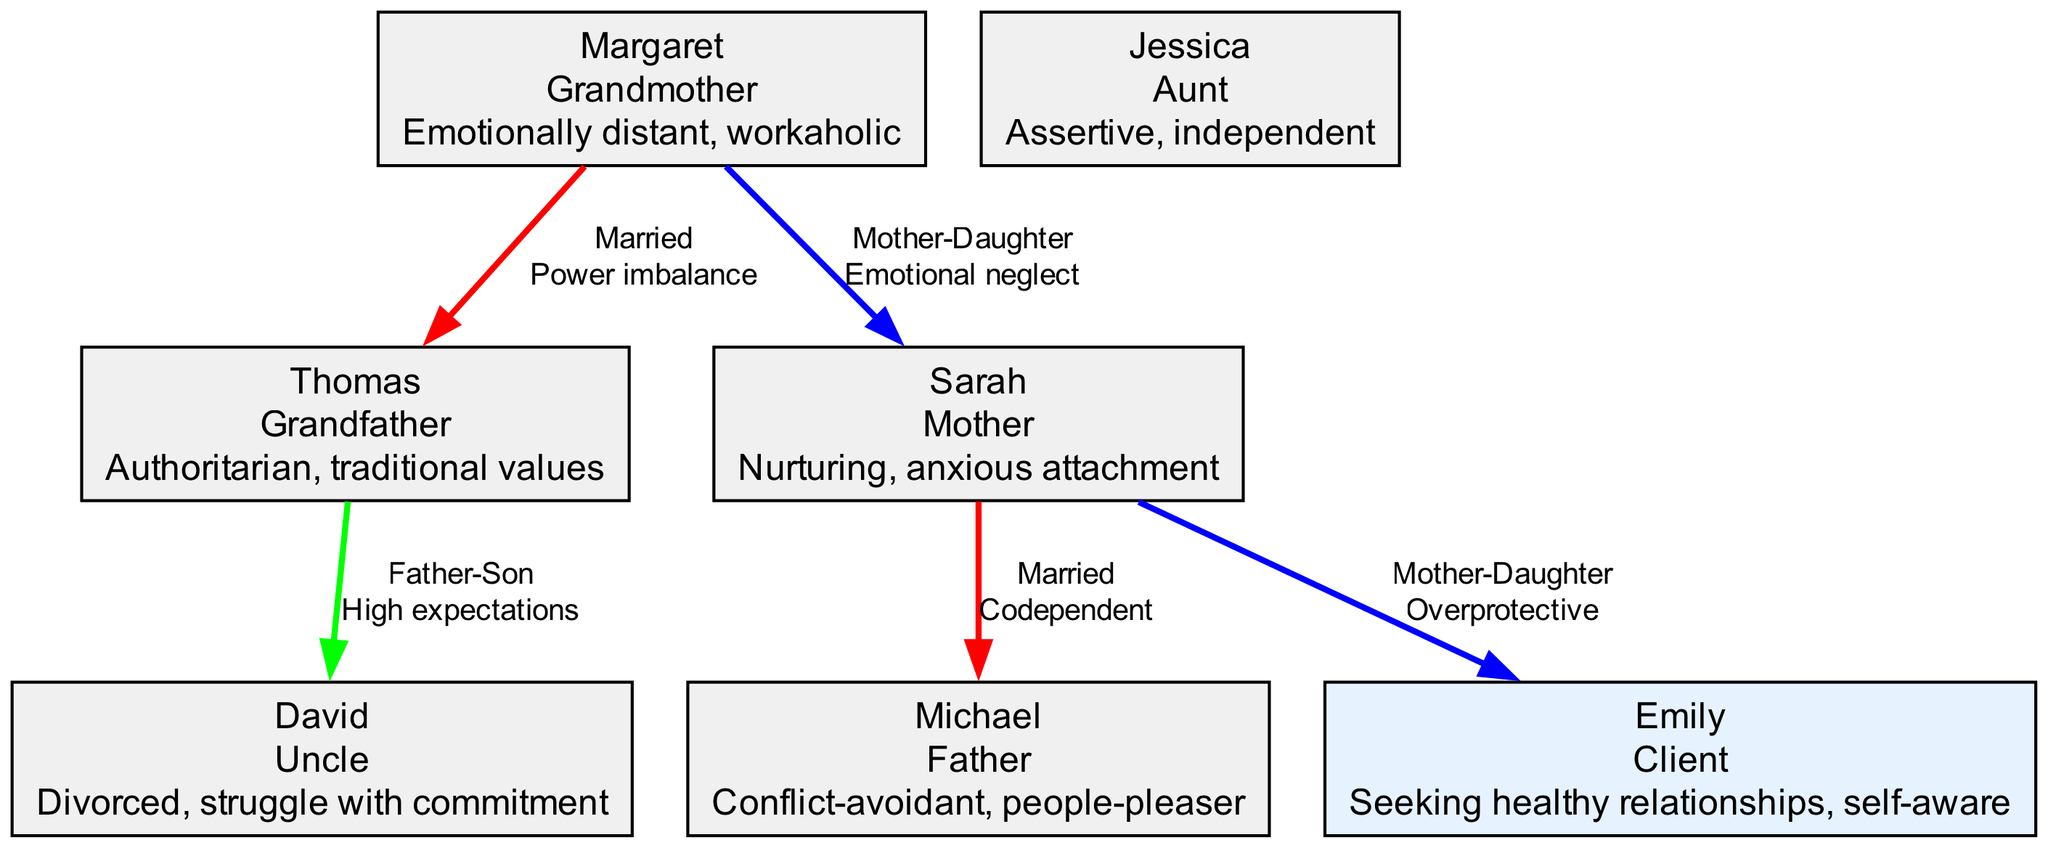What is Emily's generation? In the diagram, each family member is labeled with their respective generation. Emily is specifically identified under the "Client" category, which indicates her generation. Therefore, her generation is "Client."
Answer: Client Who is Margaret's partner? The relationships section of the diagram indicates married couples. Margaret is listed as married to Thomas, which makes him her partner.
Answer: Thomas What relationship type connects Sarah and Michael? The relationship between Sarah and Michael is labeled in the diagram as "Married." This indicates the type of connection between these two family members.
Answer: Married How many children does Sarah have? To determine the number of children Sarah has, you look for a "Mother-Daughter" relationship involving Sarah. The only relationship listed is between Sarah and Emily, indicating that Sarah has one child.
Answer: 1 What pattern exists in the relationship between David and Thomas? The relationship between David and Thomas is described in the diagram as a "Father-Son" relationship with a pattern of "High expectations." This provides insight into the dynamics between the two members.
Answer: High expectations Which family member is described as conflict-avoidant? By examining the traits of each family member listed in the diagram, we see that Michael is specifically described as "Conflict-avoidant." This directly answers the question about who possesses that trait.
Answer: Michael What is the relationship pattern between Sarah and Emily? The diagram shows a "Mother-Daughter" relationship between Sarah and Emily, specifically identifying the pattern as "Overprotective." This gives insight into the nature of their dynamic.
Answer: Overprotective Who is the aunt in this family? By looking through the family members listed in the diagram, Jessica is identified as the aunt. This is confirmed by her label as "Aunt" in the family structure.
Answer: Jessica Which family member showed emotional neglect towards Sarah? The relationship section details a "Mother-Daughter" connection between Margaret and Sarah, with the pattern identified as "Emotional neglect." Thus, Margaret is the member who exhibited this behavior.
Answer: Margaret 